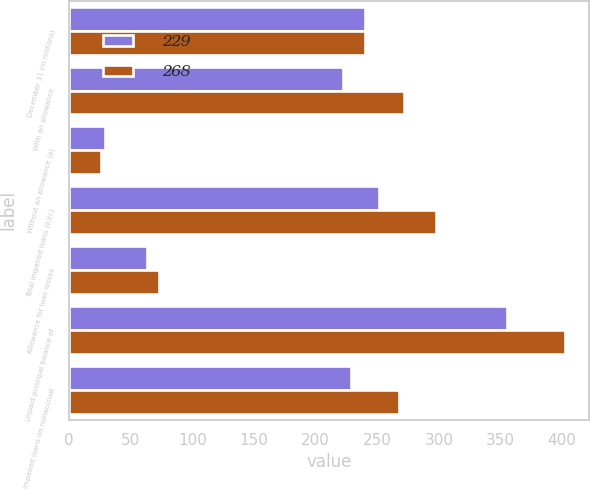Convert chart. <chart><loc_0><loc_0><loc_500><loc_500><stacked_bar_chart><ecel><fcel>December 31 (in millions)<fcel>With an allowance<fcel>Without an allowance (a)<fcel>Total impaired loans (b)(c)<fcel>Allowance for loan losses<fcel>Unpaid principal balance of<fcel>Impaired loans on nonaccrual<nl><fcel>229<fcel>240<fcel>222<fcel>29<fcel>251<fcel>63<fcel>355<fcel>229<nl><fcel>268<fcel>240<fcel>272<fcel>26<fcel>298<fcel>73<fcel>402<fcel>268<nl></chart> 